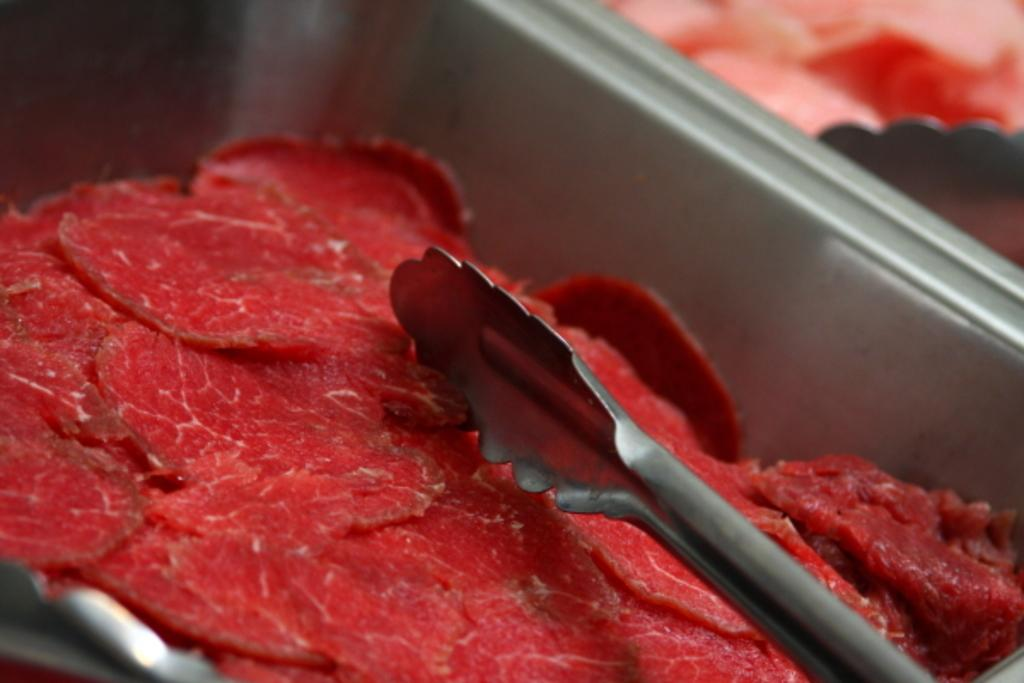What object is present in the image that can be used for holding and serving items? There is an iron tray in the image. What type of food is on the tray? The tray contains red meat. What utensil is positioned above the meat? There is a tong above the meat. What type of hearing aid is visible on the tray in the image? There is no hearing aid present in the image; it features an iron tray with red meat and a tong. What type of scissors can be seen cutting the meat in the image? There are no scissors present in the image, and the meat is not being cut. 